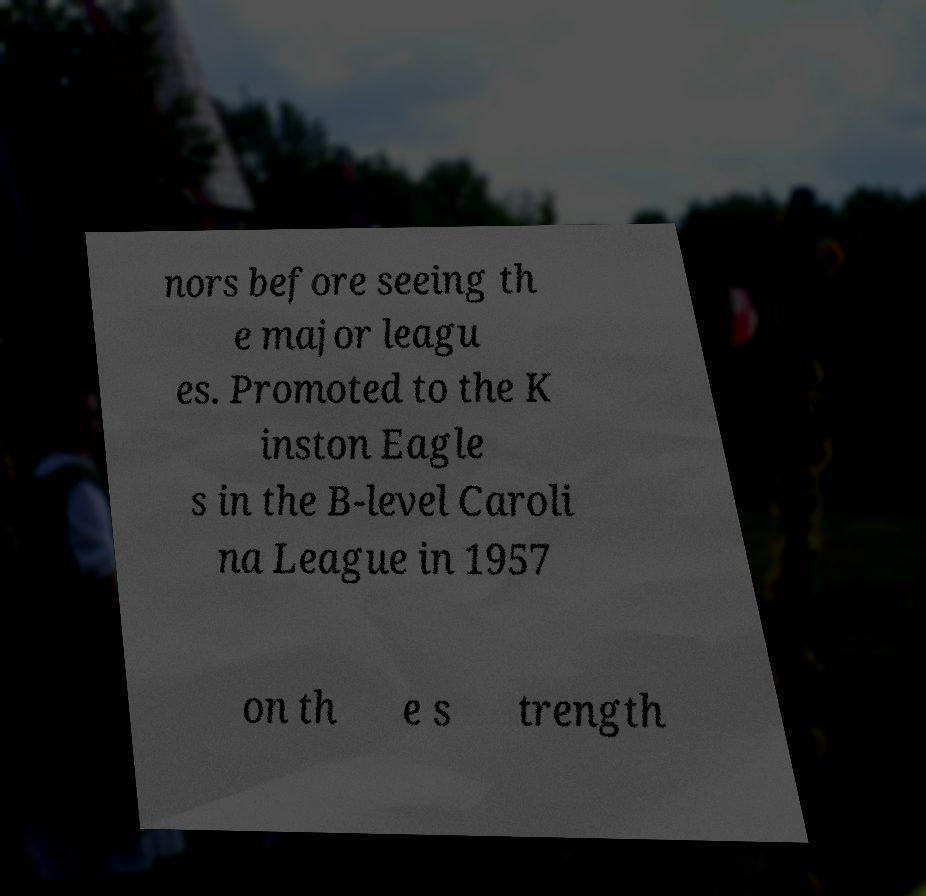For documentation purposes, I need the text within this image transcribed. Could you provide that? nors before seeing th e major leagu es. Promoted to the K inston Eagle s in the B-level Caroli na League in 1957 on th e s trength 